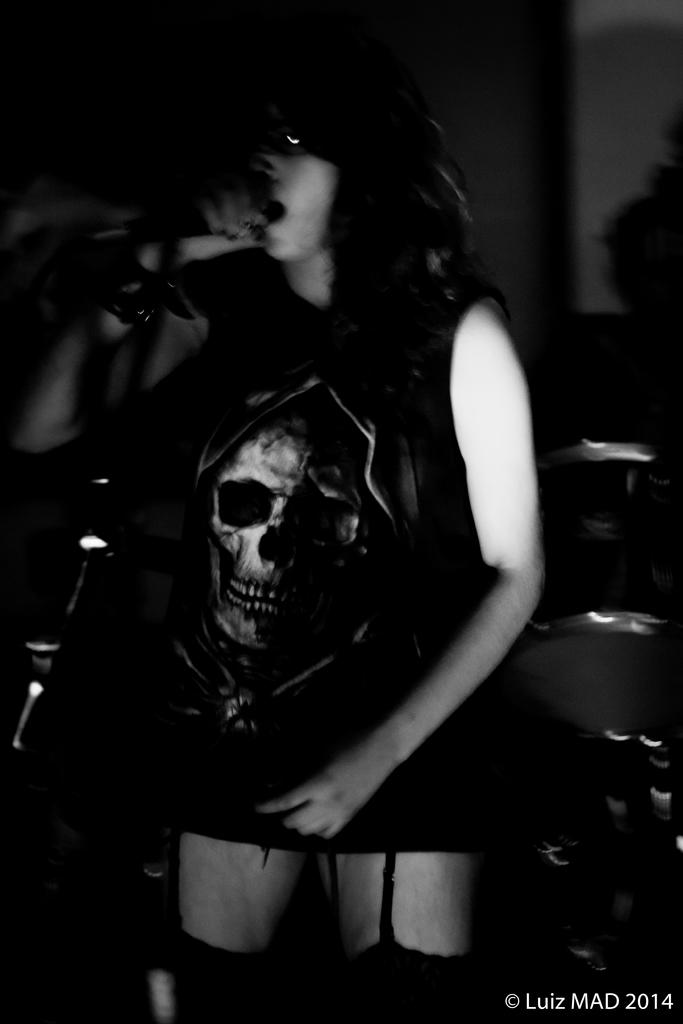What is the person in the image doing? The person in the image is holding a microphone. How is the microphone being supported? The microphone is attached to a stand. What other object related to music can be seen in the image? There is a musical instrument visible behind the person. What can be observed on the wall in the image? There is a shadow on the wall in the image. What type of clouds can be seen in the image? There are no clouds visible in the image. What kind of cloth is draped over the musical instrument in the image? There is no cloth draped over the musical instrument in the image; it is visible without any covering. 